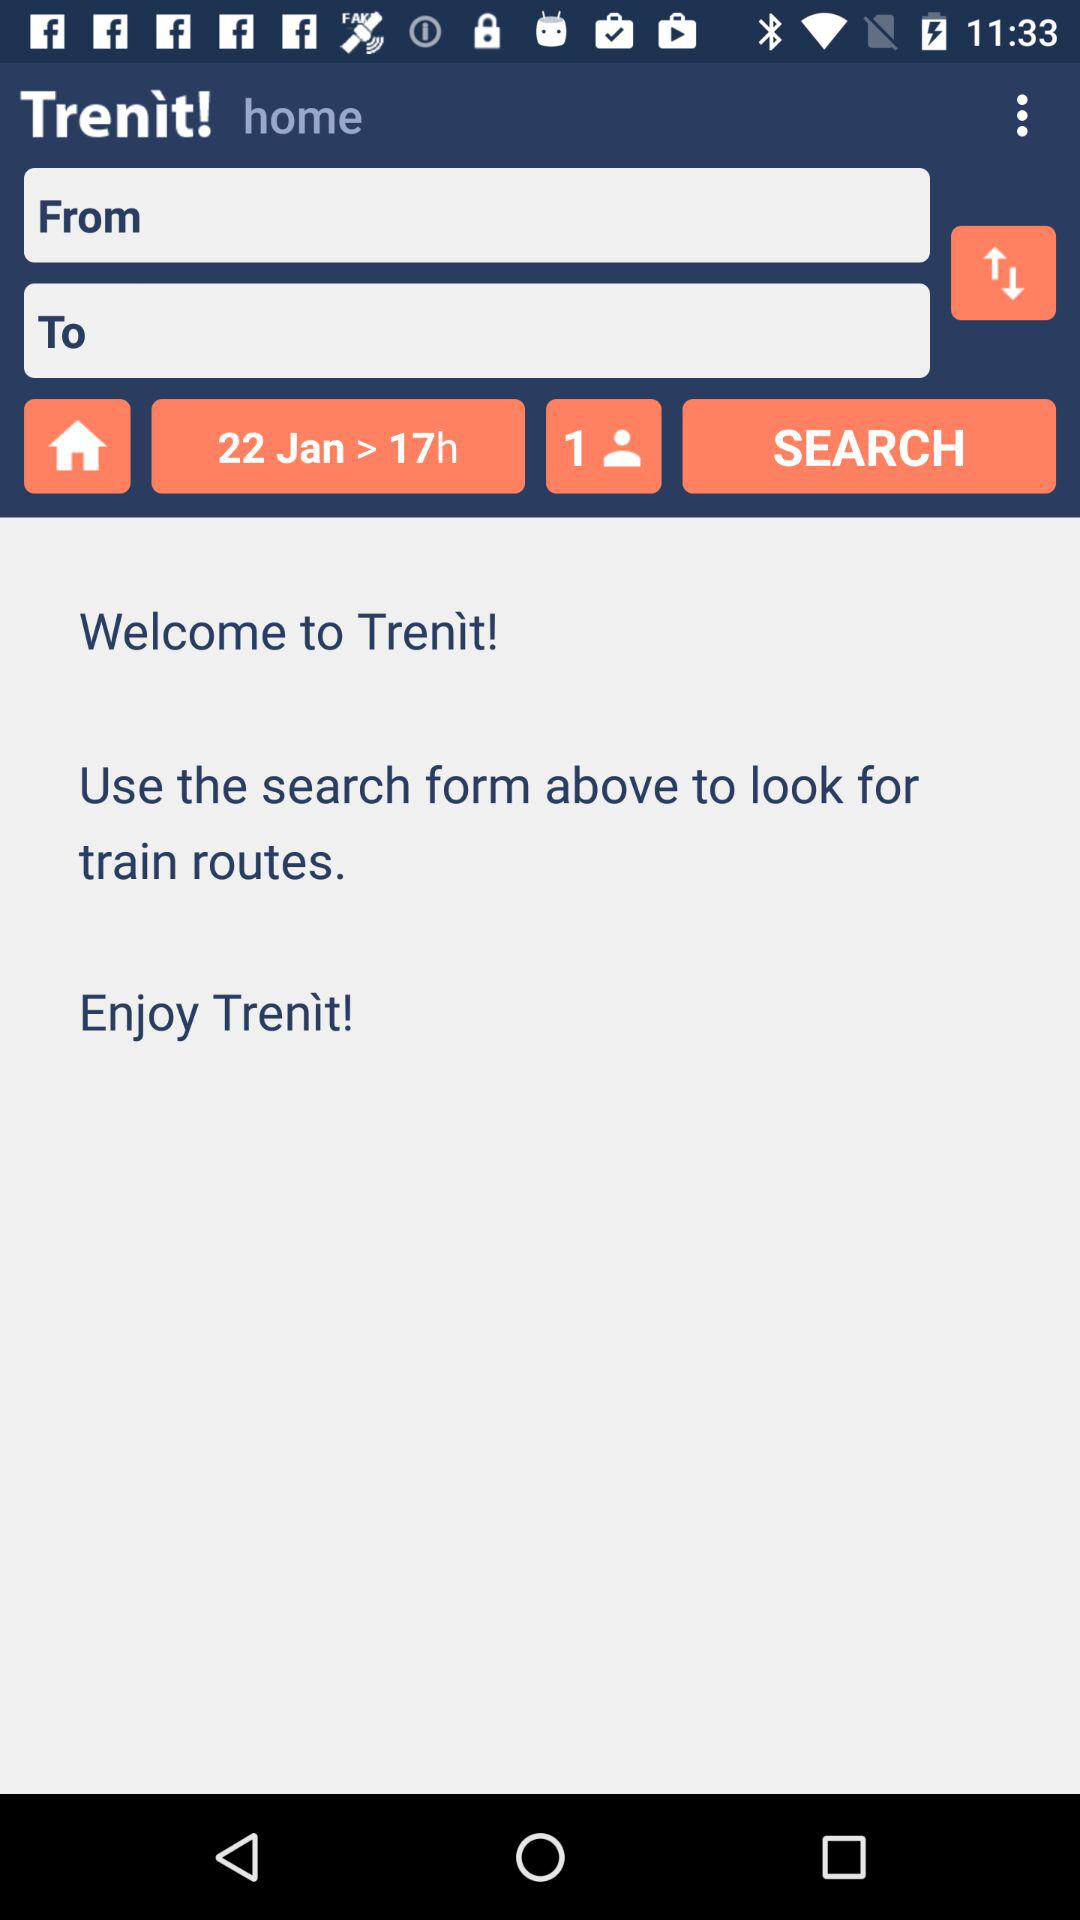What's the duration of the train journey? The duration is 17 hours. 